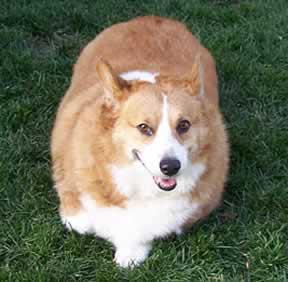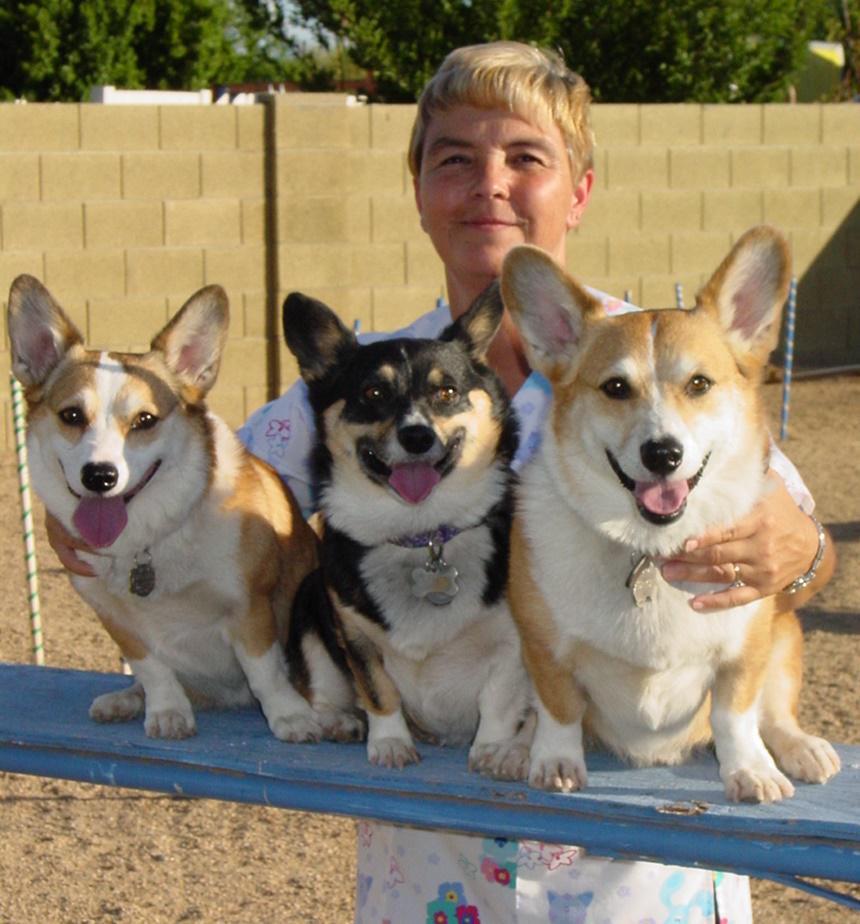The first image is the image on the left, the second image is the image on the right. For the images shown, is this caption "One image contains at least twice as many corgi dogs as the other image." true? Answer yes or no. Yes. The first image is the image on the left, the second image is the image on the right. Assess this claim about the two images: "There are at least three dogs.". Correct or not? Answer yes or no. Yes. 